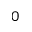<formula> <loc_0><loc_0><loc_500><loc_500>_ { 0 }</formula> 